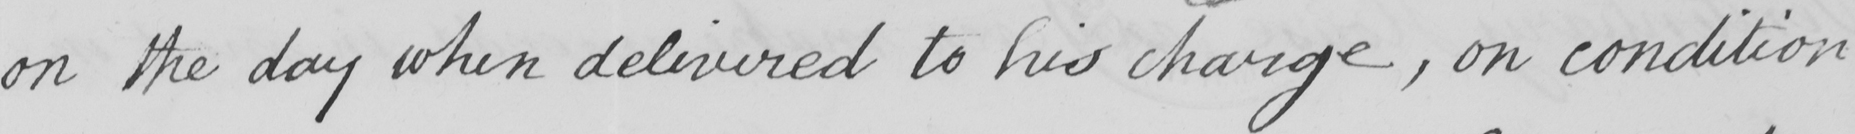Transcribe the text shown in this historical manuscript line. on the day when delivered to his charge , on condition 